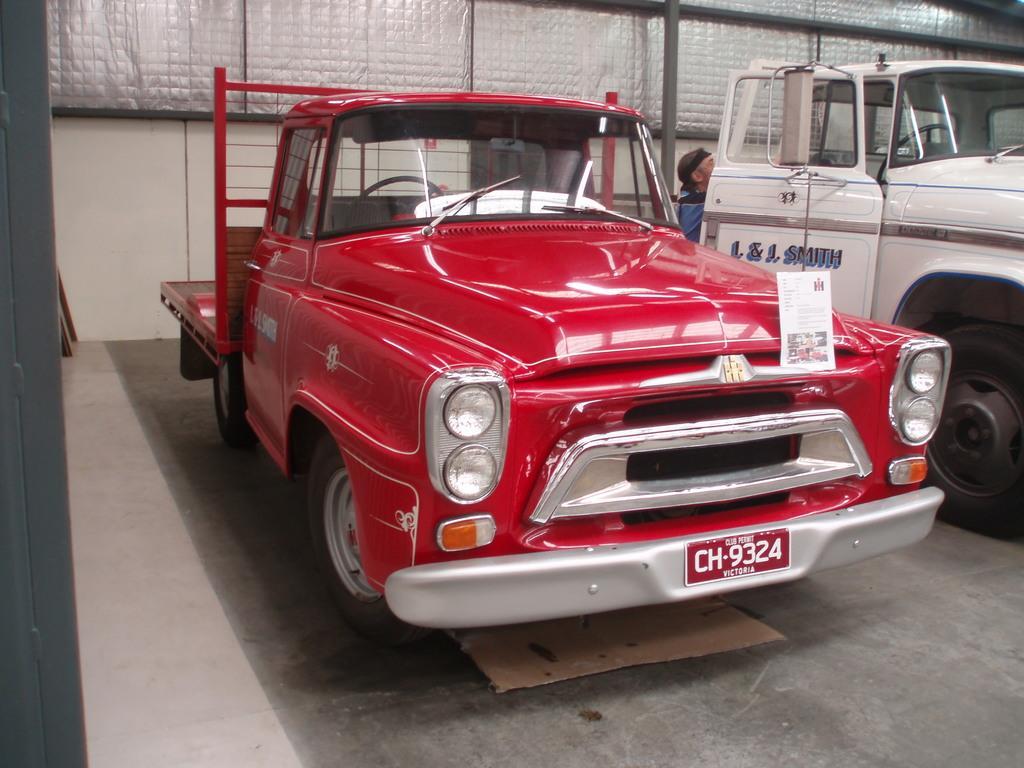Can you describe this image briefly? In this picture we can see there are some vehicles parked on the path and behind the people there is a wall and iron rods. 